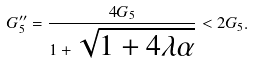<formula> <loc_0><loc_0><loc_500><loc_500>G _ { 5 } ^ { \prime \prime } = \frac { 4 G _ { 5 } } { 1 + \sqrt { 1 + 4 \lambda \alpha } } < 2 G _ { 5 } .</formula> 